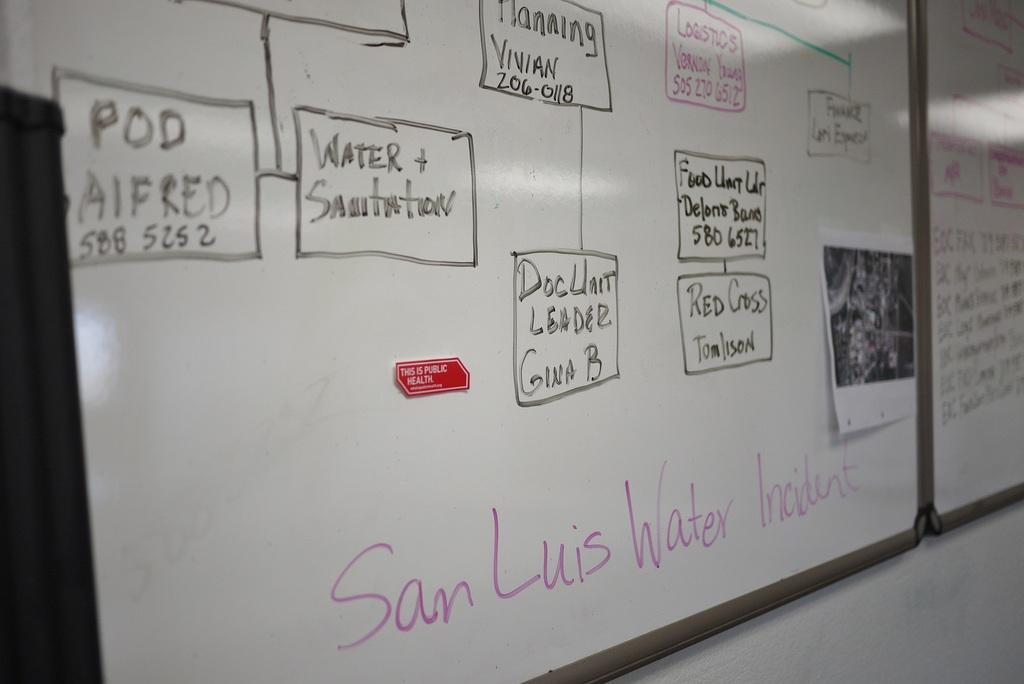Provide a one-sentence caption for the provided image. Water and Sanitation are topics written on a white board on the walls. 